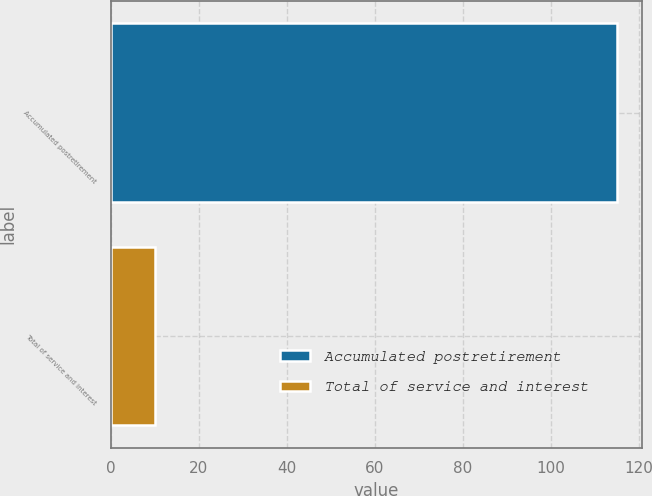Convert chart. <chart><loc_0><loc_0><loc_500><loc_500><bar_chart><fcel>Accumulated postretirement<fcel>Total of service and interest<nl><fcel>115<fcel>10<nl></chart> 